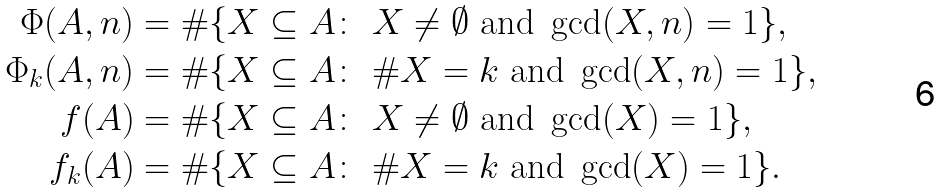<formula> <loc_0><loc_0><loc_500><loc_500>\Phi ( A , n ) & = \# \{ X \subseteq A \colon \ X \not = \emptyset \ \text {and\ } \gcd ( X , n ) = 1 \} , \\ \Phi _ { k } ( A , n ) & = \# \{ X \subseteq A \colon \ \# X = k \ \text {and\ } \gcd ( X , n ) = 1 \} , \\ f ( A ) & = \# \{ X \subseteq A \colon \ X \not = \emptyset \ \text {and\ } \gcd ( X ) = 1 \} , \\ f _ { k } ( A ) & = \# \{ X \subseteq A \colon \ \# X = k \ \text {and\ } \gcd ( X ) = 1 \} .</formula> 